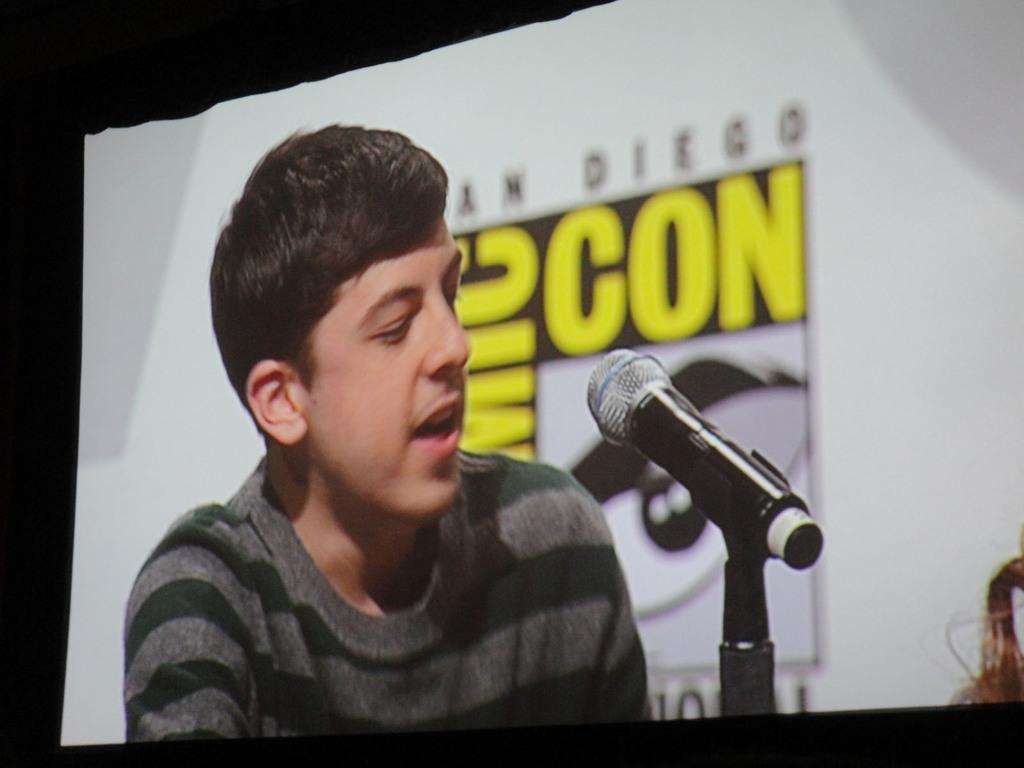What is the main object in the image? There is a screen in the image. What can be seen on the screen? A man is visible on the screen. What is the man wearing? The man is wearing a t-shirt. What device is present in the image for amplifying sound? There is a microphone (mic) in the image. What can be seen in the background of the image? There is text or writing in the background of the image. How would you describe the lighting in the image? The background is dark. What direction is the book facing in the image? There is no book present in the image. Can you describe the ocean in the image? There is no ocean present in the image. 